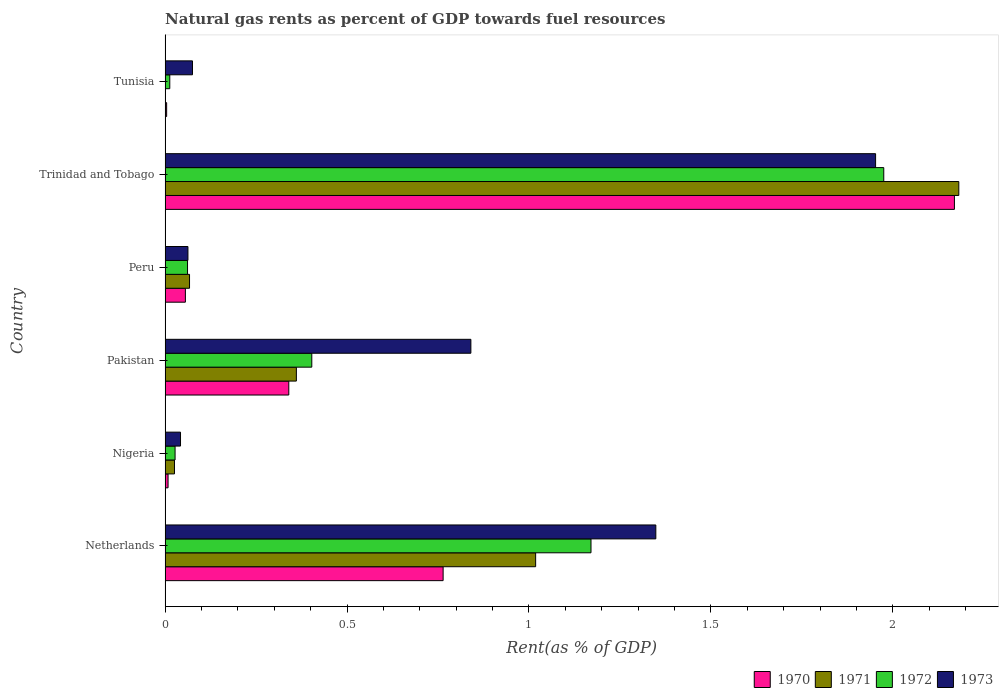Are the number of bars on each tick of the Y-axis equal?
Ensure brevity in your answer.  Yes. What is the label of the 2nd group of bars from the top?
Ensure brevity in your answer.  Trinidad and Tobago. What is the matural gas rent in 1972 in Trinidad and Tobago?
Provide a short and direct response. 1.98. Across all countries, what is the maximum matural gas rent in 1970?
Provide a short and direct response. 2.17. Across all countries, what is the minimum matural gas rent in 1973?
Offer a very short reply. 0.04. In which country was the matural gas rent in 1970 maximum?
Your answer should be very brief. Trinidad and Tobago. In which country was the matural gas rent in 1972 minimum?
Keep it short and to the point. Tunisia. What is the total matural gas rent in 1971 in the graph?
Ensure brevity in your answer.  3.65. What is the difference between the matural gas rent in 1971 in Netherlands and that in Trinidad and Tobago?
Your answer should be compact. -1.16. What is the difference between the matural gas rent in 1971 in Tunisia and the matural gas rent in 1972 in Netherlands?
Offer a very short reply. -1.17. What is the average matural gas rent in 1970 per country?
Make the answer very short. 0.56. What is the difference between the matural gas rent in 1973 and matural gas rent in 1971 in Netherlands?
Offer a very short reply. 0.33. What is the ratio of the matural gas rent in 1973 in Nigeria to that in Pakistan?
Offer a terse response. 0.05. Is the difference between the matural gas rent in 1973 in Nigeria and Trinidad and Tobago greater than the difference between the matural gas rent in 1971 in Nigeria and Trinidad and Tobago?
Offer a very short reply. Yes. What is the difference between the highest and the second highest matural gas rent in 1972?
Your response must be concise. 0.8. What is the difference between the highest and the lowest matural gas rent in 1972?
Give a very brief answer. 1.96. In how many countries, is the matural gas rent in 1973 greater than the average matural gas rent in 1973 taken over all countries?
Offer a terse response. 3. Is the sum of the matural gas rent in 1972 in Pakistan and Trinidad and Tobago greater than the maximum matural gas rent in 1971 across all countries?
Your answer should be compact. Yes. Is it the case that in every country, the sum of the matural gas rent in 1971 and matural gas rent in 1970 is greater than the sum of matural gas rent in 1972 and matural gas rent in 1973?
Offer a terse response. No. Are all the bars in the graph horizontal?
Keep it short and to the point. Yes. Are the values on the major ticks of X-axis written in scientific E-notation?
Your response must be concise. No. Does the graph contain any zero values?
Keep it short and to the point. No. Does the graph contain grids?
Your response must be concise. No. How many legend labels are there?
Provide a succinct answer. 4. What is the title of the graph?
Your answer should be very brief. Natural gas rents as percent of GDP towards fuel resources. Does "2004" appear as one of the legend labels in the graph?
Your answer should be compact. No. What is the label or title of the X-axis?
Your response must be concise. Rent(as % of GDP). What is the Rent(as % of GDP) in 1970 in Netherlands?
Keep it short and to the point. 0.76. What is the Rent(as % of GDP) in 1971 in Netherlands?
Keep it short and to the point. 1.02. What is the Rent(as % of GDP) of 1972 in Netherlands?
Provide a succinct answer. 1.17. What is the Rent(as % of GDP) of 1973 in Netherlands?
Give a very brief answer. 1.35. What is the Rent(as % of GDP) of 1970 in Nigeria?
Your answer should be compact. 0.01. What is the Rent(as % of GDP) of 1971 in Nigeria?
Provide a short and direct response. 0.03. What is the Rent(as % of GDP) in 1972 in Nigeria?
Make the answer very short. 0.03. What is the Rent(as % of GDP) of 1973 in Nigeria?
Provide a succinct answer. 0.04. What is the Rent(as % of GDP) of 1970 in Pakistan?
Provide a succinct answer. 0.34. What is the Rent(as % of GDP) in 1971 in Pakistan?
Provide a short and direct response. 0.36. What is the Rent(as % of GDP) of 1972 in Pakistan?
Your answer should be compact. 0.4. What is the Rent(as % of GDP) in 1973 in Pakistan?
Ensure brevity in your answer.  0.84. What is the Rent(as % of GDP) in 1970 in Peru?
Offer a terse response. 0.06. What is the Rent(as % of GDP) in 1971 in Peru?
Keep it short and to the point. 0.07. What is the Rent(as % of GDP) in 1972 in Peru?
Provide a succinct answer. 0.06. What is the Rent(as % of GDP) of 1973 in Peru?
Your response must be concise. 0.06. What is the Rent(as % of GDP) in 1970 in Trinidad and Tobago?
Your answer should be very brief. 2.17. What is the Rent(as % of GDP) in 1971 in Trinidad and Tobago?
Provide a short and direct response. 2.18. What is the Rent(as % of GDP) of 1972 in Trinidad and Tobago?
Offer a terse response. 1.98. What is the Rent(as % of GDP) of 1973 in Trinidad and Tobago?
Your answer should be very brief. 1.95. What is the Rent(as % of GDP) in 1970 in Tunisia?
Keep it short and to the point. 0. What is the Rent(as % of GDP) in 1971 in Tunisia?
Your response must be concise. 0. What is the Rent(as % of GDP) of 1972 in Tunisia?
Your answer should be very brief. 0.01. What is the Rent(as % of GDP) in 1973 in Tunisia?
Keep it short and to the point. 0.08. Across all countries, what is the maximum Rent(as % of GDP) in 1970?
Keep it short and to the point. 2.17. Across all countries, what is the maximum Rent(as % of GDP) of 1971?
Keep it short and to the point. 2.18. Across all countries, what is the maximum Rent(as % of GDP) of 1972?
Provide a short and direct response. 1.98. Across all countries, what is the maximum Rent(as % of GDP) of 1973?
Keep it short and to the point. 1.95. Across all countries, what is the minimum Rent(as % of GDP) of 1970?
Offer a very short reply. 0. Across all countries, what is the minimum Rent(as % of GDP) of 1971?
Your response must be concise. 0. Across all countries, what is the minimum Rent(as % of GDP) in 1972?
Provide a succinct answer. 0.01. Across all countries, what is the minimum Rent(as % of GDP) of 1973?
Keep it short and to the point. 0.04. What is the total Rent(as % of GDP) of 1970 in the graph?
Offer a terse response. 3.34. What is the total Rent(as % of GDP) in 1971 in the graph?
Keep it short and to the point. 3.65. What is the total Rent(as % of GDP) in 1972 in the graph?
Provide a succinct answer. 3.65. What is the total Rent(as % of GDP) of 1973 in the graph?
Make the answer very short. 4.32. What is the difference between the Rent(as % of GDP) of 1970 in Netherlands and that in Nigeria?
Offer a terse response. 0.76. What is the difference between the Rent(as % of GDP) of 1971 in Netherlands and that in Nigeria?
Provide a short and direct response. 0.99. What is the difference between the Rent(as % of GDP) in 1972 in Netherlands and that in Nigeria?
Make the answer very short. 1.14. What is the difference between the Rent(as % of GDP) of 1973 in Netherlands and that in Nigeria?
Offer a very short reply. 1.31. What is the difference between the Rent(as % of GDP) of 1970 in Netherlands and that in Pakistan?
Offer a terse response. 0.42. What is the difference between the Rent(as % of GDP) in 1971 in Netherlands and that in Pakistan?
Provide a short and direct response. 0.66. What is the difference between the Rent(as % of GDP) of 1972 in Netherlands and that in Pakistan?
Provide a succinct answer. 0.77. What is the difference between the Rent(as % of GDP) of 1973 in Netherlands and that in Pakistan?
Your answer should be compact. 0.51. What is the difference between the Rent(as % of GDP) in 1970 in Netherlands and that in Peru?
Ensure brevity in your answer.  0.71. What is the difference between the Rent(as % of GDP) of 1971 in Netherlands and that in Peru?
Your response must be concise. 0.95. What is the difference between the Rent(as % of GDP) in 1972 in Netherlands and that in Peru?
Offer a terse response. 1.11. What is the difference between the Rent(as % of GDP) of 1973 in Netherlands and that in Peru?
Provide a short and direct response. 1.29. What is the difference between the Rent(as % of GDP) of 1970 in Netherlands and that in Trinidad and Tobago?
Make the answer very short. -1.41. What is the difference between the Rent(as % of GDP) of 1971 in Netherlands and that in Trinidad and Tobago?
Your answer should be compact. -1.16. What is the difference between the Rent(as % of GDP) of 1972 in Netherlands and that in Trinidad and Tobago?
Offer a terse response. -0.8. What is the difference between the Rent(as % of GDP) in 1973 in Netherlands and that in Trinidad and Tobago?
Ensure brevity in your answer.  -0.6. What is the difference between the Rent(as % of GDP) of 1970 in Netherlands and that in Tunisia?
Your answer should be compact. 0.76. What is the difference between the Rent(as % of GDP) of 1971 in Netherlands and that in Tunisia?
Make the answer very short. 1.02. What is the difference between the Rent(as % of GDP) in 1972 in Netherlands and that in Tunisia?
Make the answer very short. 1.16. What is the difference between the Rent(as % of GDP) in 1973 in Netherlands and that in Tunisia?
Give a very brief answer. 1.27. What is the difference between the Rent(as % of GDP) of 1970 in Nigeria and that in Pakistan?
Your answer should be compact. -0.33. What is the difference between the Rent(as % of GDP) of 1971 in Nigeria and that in Pakistan?
Provide a short and direct response. -0.34. What is the difference between the Rent(as % of GDP) in 1972 in Nigeria and that in Pakistan?
Your answer should be very brief. -0.38. What is the difference between the Rent(as % of GDP) of 1973 in Nigeria and that in Pakistan?
Offer a terse response. -0.8. What is the difference between the Rent(as % of GDP) in 1970 in Nigeria and that in Peru?
Your answer should be very brief. -0.05. What is the difference between the Rent(as % of GDP) in 1971 in Nigeria and that in Peru?
Provide a succinct answer. -0.04. What is the difference between the Rent(as % of GDP) in 1972 in Nigeria and that in Peru?
Offer a very short reply. -0.03. What is the difference between the Rent(as % of GDP) in 1973 in Nigeria and that in Peru?
Provide a succinct answer. -0.02. What is the difference between the Rent(as % of GDP) in 1970 in Nigeria and that in Trinidad and Tobago?
Provide a succinct answer. -2.16. What is the difference between the Rent(as % of GDP) in 1971 in Nigeria and that in Trinidad and Tobago?
Your answer should be very brief. -2.16. What is the difference between the Rent(as % of GDP) in 1972 in Nigeria and that in Trinidad and Tobago?
Keep it short and to the point. -1.95. What is the difference between the Rent(as % of GDP) in 1973 in Nigeria and that in Trinidad and Tobago?
Keep it short and to the point. -1.91. What is the difference between the Rent(as % of GDP) of 1970 in Nigeria and that in Tunisia?
Keep it short and to the point. 0. What is the difference between the Rent(as % of GDP) in 1971 in Nigeria and that in Tunisia?
Ensure brevity in your answer.  0.03. What is the difference between the Rent(as % of GDP) of 1972 in Nigeria and that in Tunisia?
Offer a terse response. 0.01. What is the difference between the Rent(as % of GDP) in 1973 in Nigeria and that in Tunisia?
Provide a succinct answer. -0.03. What is the difference between the Rent(as % of GDP) of 1970 in Pakistan and that in Peru?
Provide a short and direct response. 0.28. What is the difference between the Rent(as % of GDP) in 1971 in Pakistan and that in Peru?
Your response must be concise. 0.29. What is the difference between the Rent(as % of GDP) in 1972 in Pakistan and that in Peru?
Ensure brevity in your answer.  0.34. What is the difference between the Rent(as % of GDP) of 1973 in Pakistan and that in Peru?
Your answer should be compact. 0.78. What is the difference between the Rent(as % of GDP) of 1970 in Pakistan and that in Trinidad and Tobago?
Offer a very short reply. -1.83. What is the difference between the Rent(as % of GDP) in 1971 in Pakistan and that in Trinidad and Tobago?
Ensure brevity in your answer.  -1.82. What is the difference between the Rent(as % of GDP) of 1972 in Pakistan and that in Trinidad and Tobago?
Give a very brief answer. -1.57. What is the difference between the Rent(as % of GDP) in 1973 in Pakistan and that in Trinidad and Tobago?
Make the answer very short. -1.11. What is the difference between the Rent(as % of GDP) of 1970 in Pakistan and that in Tunisia?
Ensure brevity in your answer.  0.34. What is the difference between the Rent(as % of GDP) in 1971 in Pakistan and that in Tunisia?
Make the answer very short. 0.36. What is the difference between the Rent(as % of GDP) of 1972 in Pakistan and that in Tunisia?
Make the answer very short. 0.39. What is the difference between the Rent(as % of GDP) of 1973 in Pakistan and that in Tunisia?
Ensure brevity in your answer.  0.77. What is the difference between the Rent(as % of GDP) in 1970 in Peru and that in Trinidad and Tobago?
Make the answer very short. -2.11. What is the difference between the Rent(as % of GDP) of 1971 in Peru and that in Trinidad and Tobago?
Provide a short and direct response. -2.11. What is the difference between the Rent(as % of GDP) in 1972 in Peru and that in Trinidad and Tobago?
Keep it short and to the point. -1.91. What is the difference between the Rent(as % of GDP) of 1973 in Peru and that in Trinidad and Tobago?
Provide a short and direct response. -1.89. What is the difference between the Rent(as % of GDP) in 1970 in Peru and that in Tunisia?
Offer a terse response. 0.05. What is the difference between the Rent(as % of GDP) of 1971 in Peru and that in Tunisia?
Give a very brief answer. 0.07. What is the difference between the Rent(as % of GDP) in 1972 in Peru and that in Tunisia?
Give a very brief answer. 0.05. What is the difference between the Rent(as % of GDP) in 1973 in Peru and that in Tunisia?
Provide a short and direct response. -0.01. What is the difference between the Rent(as % of GDP) in 1970 in Trinidad and Tobago and that in Tunisia?
Make the answer very short. 2.17. What is the difference between the Rent(as % of GDP) in 1971 in Trinidad and Tobago and that in Tunisia?
Provide a succinct answer. 2.18. What is the difference between the Rent(as % of GDP) of 1972 in Trinidad and Tobago and that in Tunisia?
Offer a very short reply. 1.96. What is the difference between the Rent(as % of GDP) in 1973 in Trinidad and Tobago and that in Tunisia?
Make the answer very short. 1.88. What is the difference between the Rent(as % of GDP) of 1970 in Netherlands and the Rent(as % of GDP) of 1971 in Nigeria?
Offer a terse response. 0.74. What is the difference between the Rent(as % of GDP) in 1970 in Netherlands and the Rent(as % of GDP) in 1972 in Nigeria?
Offer a very short reply. 0.74. What is the difference between the Rent(as % of GDP) of 1970 in Netherlands and the Rent(as % of GDP) of 1973 in Nigeria?
Your answer should be compact. 0.72. What is the difference between the Rent(as % of GDP) in 1971 in Netherlands and the Rent(as % of GDP) in 1972 in Nigeria?
Provide a short and direct response. 0.99. What is the difference between the Rent(as % of GDP) in 1972 in Netherlands and the Rent(as % of GDP) in 1973 in Nigeria?
Make the answer very short. 1.13. What is the difference between the Rent(as % of GDP) of 1970 in Netherlands and the Rent(as % of GDP) of 1971 in Pakistan?
Ensure brevity in your answer.  0.4. What is the difference between the Rent(as % of GDP) in 1970 in Netherlands and the Rent(as % of GDP) in 1972 in Pakistan?
Your response must be concise. 0.36. What is the difference between the Rent(as % of GDP) in 1970 in Netherlands and the Rent(as % of GDP) in 1973 in Pakistan?
Your response must be concise. -0.08. What is the difference between the Rent(as % of GDP) of 1971 in Netherlands and the Rent(as % of GDP) of 1972 in Pakistan?
Your response must be concise. 0.62. What is the difference between the Rent(as % of GDP) of 1971 in Netherlands and the Rent(as % of GDP) of 1973 in Pakistan?
Give a very brief answer. 0.18. What is the difference between the Rent(as % of GDP) of 1972 in Netherlands and the Rent(as % of GDP) of 1973 in Pakistan?
Give a very brief answer. 0.33. What is the difference between the Rent(as % of GDP) of 1970 in Netherlands and the Rent(as % of GDP) of 1971 in Peru?
Make the answer very short. 0.7. What is the difference between the Rent(as % of GDP) in 1970 in Netherlands and the Rent(as % of GDP) in 1972 in Peru?
Provide a succinct answer. 0.7. What is the difference between the Rent(as % of GDP) of 1970 in Netherlands and the Rent(as % of GDP) of 1973 in Peru?
Your answer should be compact. 0.7. What is the difference between the Rent(as % of GDP) in 1971 in Netherlands and the Rent(as % of GDP) in 1972 in Peru?
Offer a terse response. 0.96. What is the difference between the Rent(as % of GDP) of 1971 in Netherlands and the Rent(as % of GDP) of 1973 in Peru?
Offer a very short reply. 0.96. What is the difference between the Rent(as % of GDP) in 1972 in Netherlands and the Rent(as % of GDP) in 1973 in Peru?
Your response must be concise. 1.11. What is the difference between the Rent(as % of GDP) of 1970 in Netherlands and the Rent(as % of GDP) of 1971 in Trinidad and Tobago?
Provide a succinct answer. -1.42. What is the difference between the Rent(as % of GDP) of 1970 in Netherlands and the Rent(as % of GDP) of 1972 in Trinidad and Tobago?
Your answer should be very brief. -1.21. What is the difference between the Rent(as % of GDP) of 1970 in Netherlands and the Rent(as % of GDP) of 1973 in Trinidad and Tobago?
Give a very brief answer. -1.19. What is the difference between the Rent(as % of GDP) of 1971 in Netherlands and the Rent(as % of GDP) of 1972 in Trinidad and Tobago?
Provide a succinct answer. -0.96. What is the difference between the Rent(as % of GDP) in 1971 in Netherlands and the Rent(as % of GDP) in 1973 in Trinidad and Tobago?
Offer a very short reply. -0.93. What is the difference between the Rent(as % of GDP) of 1972 in Netherlands and the Rent(as % of GDP) of 1973 in Trinidad and Tobago?
Make the answer very short. -0.78. What is the difference between the Rent(as % of GDP) of 1970 in Netherlands and the Rent(as % of GDP) of 1971 in Tunisia?
Provide a succinct answer. 0.76. What is the difference between the Rent(as % of GDP) of 1970 in Netherlands and the Rent(as % of GDP) of 1972 in Tunisia?
Ensure brevity in your answer.  0.75. What is the difference between the Rent(as % of GDP) in 1970 in Netherlands and the Rent(as % of GDP) in 1973 in Tunisia?
Make the answer very short. 0.69. What is the difference between the Rent(as % of GDP) of 1971 in Netherlands and the Rent(as % of GDP) of 1972 in Tunisia?
Offer a terse response. 1.01. What is the difference between the Rent(as % of GDP) in 1971 in Netherlands and the Rent(as % of GDP) in 1973 in Tunisia?
Give a very brief answer. 0.94. What is the difference between the Rent(as % of GDP) in 1972 in Netherlands and the Rent(as % of GDP) in 1973 in Tunisia?
Keep it short and to the point. 1.1. What is the difference between the Rent(as % of GDP) of 1970 in Nigeria and the Rent(as % of GDP) of 1971 in Pakistan?
Provide a short and direct response. -0.35. What is the difference between the Rent(as % of GDP) of 1970 in Nigeria and the Rent(as % of GDP) of 1972 in Pakistan?
Provide a succinct answer. -0.4. What is the difference between the Rent(as % of GDP) in 1970 in Nigeria and the Rent(as % of GDP) in 1973 in Pakistan?
Make the answer very short. -0.83. What is the difference between the Rent(as % of GDP) in 1971 in Nigeria and the Rent(as % of GDP) in 1972 in Pakistan?
Your answer should be very brief. -0.38. What is the difference between the Rent(as % of GDP) in 1971 in Nigeria and the Rent(as % of GDP) in 1973 in Pakistan?
Give a very brief answer. -0.81. What is the difference between the Rent(as % of GDP) in 1972 in Nigeria and the Rent(as % of GDP) in 1973 in Pakistan?
Your answer should be compact. -0.81. What is the difference between the Rent(as % of GDP) in 1970 in Nigeria and the Rent(as % of GDP) in 1971 in Peru?
Offer a very short reply. -0.06. What is the difference between the Rent(as % of GDP) of 1970 in Nigeria and the Rent(as % of GDP) of 1972 in Peru?
Offer a terse response. -0.05. What is the difference between the Rent(as % of GDP) in 1970 in Nigeria and the Rent(as % of GDP) in 1973 in Peru?
Provide a succinct answer. -0.05. What is the difference between the Rent(as % of GDP) in 1971 in Nigeria and the Rent(as % of GDP) in 1972 in Peru?
Provide a succinct answer. -0.04. What is the difference between the Rent(as % of GDP) in 1971 in Nigeria and the Rent(as % of GDP) in 1973 in Peru?
Provide a short and direct response. -0.04. What is the difference between the Rent(as % of GDP) in 1972 in Nigeria and the Rent(as % of GDP) in 1973 in Peru?
Your answer should be compact. -0.04. What is the difference between the Rent(as % of GDP) in 1970 in Nigeria and the Rent(as % of GDP) in 1971 in Trinidad and Tobago?
Your answer should be very brief. -2.17. What is the difference between the Rent(as % of GDP) of 1970 in Nigeria and the Rent(as % of GDP) of 1972 in Trinidad and Tobago?
Provide a short and direct response. -1.97. What is the difference between the Rent(as % of GDP) of 1970 in Nigeria and the Rent(as % of GDP) of 1973 in Trinidad and Tobago?
Make the answer very short. -1.94. What is the difference between the Rent(as % of GDP) of 1971 in Nigeria and the Rent(as % of GDP) of 1972 in Trinidad and Tobago?
Your answer should be very brief. -1.95. What is the difference between the Rent(as % of GDP) in 1971 in Nigeria and the Rent(as % of GDP) in 1973 in Trinidad and Tobago?
Provide a succinct answer. -1.93. What is the difference between the Rent(as % of GDP) in 1972 in Nigeria and the Rent(as % of GDP) in 1973 in Trinidad and Tobago?
Ensure brevity in your answer.  -1.93. What is the difference between the Rent(as % of GDP) of 1970 in Nigeria and the Rent(as % of GDP) of 1971 in Tunisia?
Ensure brevity in your answer.  0.01. What is the difference between the Rent(as % of GDP) in 1970 in Nigeria and the Rent(as % of GDP) in 1972 in Tunisia?
Your response must be concise. -0. What is the difference between the Rent(as % of GDP) in 1970 in Nigeria and the Rent(as % of GDP) in 1973 in Tunisia?
Keep it short and to the point. -0.07. What is the difference between the Rent(as % of GDP) of 1971 in Nigeria and the Rent(as % of GDP) of 1972 in Tunisia?
Provide a succinct answer. 0.01. What is the difference between the Rent(as % of GDP) in 1971 in Nigeria and the Rent(as % of GDP) in 1973 in Tunisia?
Provide a succinct answer. -0.05. What is the difference between the Rent(as % of GDP) in 1972 in Nigeria and the Rent(as % of GDP) in 1973 in Tunisia?
Provide a succinct answer. -0.05. What is the difference between the Rent(as % of GDP) of 1970 in Pakistan and the Rent(as % of GDP) of 1971 in Peru?
Offer a terse response. 0.27. What is the difference between the Rent(as % of GDP) of 1970 in Pakistan and the Rent(as % of GDP) of 1972 in Peru?
Offer a terse response. 0.28. What is the difference between the Rent(as % of GDP) in 1970 in Pakistan and the Rent(as % of GDP) in 1973 in Peru?
Keep it short and to the point. 0.28. What is the difference between the Rent(as % of GDP) in 1971 in Pakistan and the Rent(as % of GDP) in 1972 in Peru?
Give a very brief answer. 0.3. What is the difference between the Rent(as % of GDP) of 1971 in Pakistan and the Rent(as % of GDP) of 1973 in Peru?
Provide a succinct answer. 0.3. What is the difference between the Rent(as % of GDP) of 1972 in Pakistan and the Rent(as % of GDP) of 1973 in Peru?
Give a very brief answer. 0.34. What is the difference between the Rent(as % of GDP) of 1970 in Pakistan and the Rent(as % of GDP) of 1971 in Trinidad and Tobago?
Make the answer very short. -1.84. What is the difference between the Rent(as % of GDP) of 1970 in Pakistan and the Rent(as % of GDP) of 1972 in Trinidad and Tobago?
Ensure brevity in your answer.  -1.64. What is the difference between the Rent(as % of GDP) in 1970 in Pakistan and the Rent(as % of GDP) in 1973 in Trinidad and Tobago?
Your answer should be very brief. -1.61. What is the difference between the Rent(as % of GDP) of 1971 in Pakistan and the Rent(as % of GDP) of 1972 in Trinidad and Tobago?
Your answer should be compact. -1.61. What is the difference between the Rent(as % of GDP) of 1971 in Pakistan and the Rent(as % of GDP) of 1973 in Trinidad and Tobago?
Provide a short and direct response. -1.59. What is the difference between the Rent(as % of GDP) in 1972 in Pakistan and the Rent(as % of GDP) in 1973 in Trinidad and Tobago?
Provide a short and direct response. -1.55. What is the difference between the Rent(as % of GDP) of 1970 in Pakistan and the Rent(as % of GDP) of 1971 in Tunisia?
Provide a short and direct response. 0.34. What is the difference between the Rent(as % of GDP) of 1970 in Pakistan and the Rent(as % of GDP) of 1972 in Tunisia?
Offer a terse response. 0.33. What is the difference between the Rent(as % of GDP) of 1970 in Pakistan and the Rent(as % of GDP) of 1973 in Tunisia?
Provide a succinct answer. 0.26. What is the difference between the Rent(as % of GDP) of 1971 in Pakistan and the Rent(as % of GDP) of 1972 in Tunisia?
Keep it short and to the point. 0.35. What is the difference between the Rent(as % of GDP) of 1971 in Pakistan and the Rent(as % of GDP) of 1973 in Tunisia?
Your response must be concise. 0.29. What is the difference between the Rent(as % of GDP) of 1972 in Pakistan and the Rent(as % of GDP) of 1973 in Tunisia?
Ensure brevity in your answer.  0.33. What is the difference between the Rent(as % of GDP) of 1970 in Peru and the Rent(as % of GDP) of 1971 in Trinidad and Tobago?
Keep it short and to the point. -2.13. What is the difference between the Rent(as % of GDP) of 1970 in Peru and the Rent(as % of GDP) of 1972 in Trinidad and Tobago?
Make the answer very short. -1.92. What is the difference between the Rent(as % of GDP) of 1970 in Peru and the Rent(as % of GDP) of 1973 in Trinidad and Tobago?
Keep it short and to the point. -1.9. What is the difference between the Rent(as % of GDP) in 1971 in Peru and the Rent(as % of GDP) in 1972 in Trinidad and Tobago?
Your answer should be very brief. -1.91. What is the difference between the Rent(as % of GDP) of 1971 in Peru and the Rent(as % of GDP) of 1973 in Trinidad and Tobago?
Provide a succinct answer. -1.89. What is the difference between the Rent(as % of GDP) in 1972 in Peru and the Rent(as % of GDP) in 1973 in Trinidad and Tobago?
Your response must be concise. -1.89. What is the difference between the Rent(as % of GDP) in 1970 in Peru and the Rent(as % of GDP) in 1971 in Tunisia?
Ensure brevity in your answer.  0.06. What is the difference between the Rent(as % of GDP) of 1970 in Peru and the Rent(as % of GDP) of 1972 in Tunisia?
Provide a succinct answer. 0.04. What is the difference between the Rent(as % of GDP) in 1970 in Peru and the Rent(as % of GDP) in 1973 in Tunisia?
Give a very brief answer. -0.02. What is the difference between the Rent(as % of GDP) of 1971 in Peru and the Rent(as % of GDP) of 1972 in Tunisia?
Your answer should be very brief. 0.05. What is the difference between the Rent(as % of GDP) in 1971 in Peru and the Rent(as % of GDP) in 1973 in Tunisia?
Provide a short and direct response. -0.01. What is the difference between the Rent(as % of GDP) in 1972 in Peru and the Rent(as % of GDP) in 1973 in Tunisia?
Your answer should be very brief. -0.01. What is the difference between the Rent(as % of GDP) of 1970 in Trinidad and Tobago and the Rent(as % of GDP) of 1971 in Tunisia?
Make the answer very short. 2.17. What is the difference between the Rent(as % of GDP) of 1970 in Trinidad and Tobago and the Rent(as % of GDP) of 1972 in Tunisia?
Your response must be concise. 2.16. What is the difference between the Rent(as % of GDP) in 1970 in Trinidad and Tobago and the Rent(as % of GDP) in 1973 in Tunisia?
Keep it short and to the point. 2.09. What is the difference between the Rent(as % of GDP) of 1971 in Trinidad and Tobago and the Rent(as % of GDP) of 1972 in Tunisia?
Keep it short and to the point. 2.17. What is the difference between the Rent(as % of GDP) in 1971 in Trinidad and Tobago and the Rent(as % of GDP) in 1973 in Tunisia?
Your answer should be compact. 2.11. What is the difference between the Rent(as % of GDP) of 1972 in Trinidad and Tobago and the Rent(as % of GDP) of 1973 in Tunisia?
Your answer should be very brief. 1.9. What is the average Rent(as % of GDP) of 1970 per country?
Provide a short and direct response. 0.56. What is the average Rent(as % of GDP) in 1971 per country?
Your answer should be very brief. 0.61. What is the average Rent(as % of GDP) in 1972 per country?
Give a very brief answer. 0.61. What is the average Rent(as % of GDP) in 1973 per country?
Provide a succinct answer. 0.72. What is the difference between the Rent(as % of GDP) of 1970 and Rent(as % of GDP) of 1971 in Netherlands?
Make the answer very short. -0.25. What is the difference between the Rent(as % of GDP) of 1970 and Rent(as % of GDP) of 1972 in Netherlands?
Your response must be concise. -0.41. What is the difference between the Rent(as % of GDP) of 1970 and Rent(as % of GDP) of 1973 in Netherlands?
Offer a very short reply. -0.58. What is the difference between the Rent(as % of GDP) in 1971 and Rent(as % of GDP) in 1972 in Netherlands?
Ensure brevity in your answer.  -0.15. What is the difference between the Rent(as % of GDP) of 1971 and Rent(as % of GDP) of 1973 in Netherlands?
Provide a short and direct response. -0.33. What is the difference between the Rent(as % of GDP) in 1972 and Rent(as % of GDP) in 1973 in Netherlands?
Your answer should be very brief. -0.18. What is the difference between the Rent(as % of GDP) in 1970 and Rent(as % of GDP) in 1971 in Nigeria?
Provide a succinct answer. -0.02. What is the difference between the Rent(as % of GDP) in 1970 and Rent(as % of GDP) in 1972 in Nigeria?
Provide a short and direct response. -0.02. What is the difference between the Rent(as % of GDP) in 1970 and Rent(as % of GDP) in 1973 in Nigeria?
Your answer should be compact. -0.03. What is the difference between the Rent(as % of GDP) in 1971 and Rent(as % of GDP) in 1972 in Nigeria?
Keep it short and to the point. -0. What is the difference between the Rent(as % of GDP) in 1971 and Rent(as % of GDP) in 1973 in Nigeria?
Provide a succinct answer. -0.02. What is the difference between the Rent(as % of GDP) in 1972 and Rent(as % of GDP) in 1973 in Nigeria?
Keep it short and to the point. -0.01. What is the difference between the Rent(as % of GDP) in 1970 and Rent(as % of GDP) in 1971 in Pakistan?
Ensure brevity in your answer.  -0.02. What is the difference between the Rent(as % of GDP) in 1970 and Rent(as % of GDP) in 1972 in Pakistan?
Keep it short and to the point. -0.06. What is the difference between the Rent(as % of GDP) in 1970 and Rent(as % of GDP) in 1973 in Pakistan?
Your answer should be very brief. -0.5. What is the difference between the Rent(as % of GDP) in 1971 and Rent(as % of GDP) in 1972 in Pakistan?
Offer a very short reply. -0.04. What is the difference between the Rent(as % of GDP) in 1971 and Rent(as % of GDP) in 1973 in Pakistan?
Offer a terse response. -0.48. What is the difference between the Rent(as % of GDP) in 1972 and Rent(as % of GDP) in 1973 in Pakistan?
Offer a terse response. -0.44. What is the difference between the Rent(as % of GDP) in 1970 and Rent(as % of GDP) in 1971 in Peru?
Provide a succinct answer. -0.01. What is the difference between the Rent(as % of GDP) of 1970 and Rent(as % of GDP) of 1972 in Peru?
Offer a terse response. -0.01. What is the difference between the Rent(as % of GDP) in 1970 and Rent(as % of GDP) in 1973 in Peru?
Make the answer very short. -0.01. What is the difference between the Rent(as % of GDP) of 1971 and Rent(as % of GDP) of 1972 in Peru?
Your answer should be very brief. 0.01. What is the difference between the Rent(as % of GDP) in 1971 and Rent(as % of GDP) in 1973 in Peru?
Your answer should be compact. 0. What is the difference between the Rent(as % of GDP) in 1972 and Rent(as % of GDP) in 1973 in Peru?
Your response must be concise. -0. What is the difference between the Rent(as % of GDP) of 1970 and Rent(as % of GDP) of 1971 in Trinidad and Tobago?
Provide a succinct answer. -0.01. What is the difference between the Rent(as % of GDP) in 1970 and Rent(as % of GDP) in 1972 in Trinidad and Tobago?
Offer a terse response. 0.19. What is the difference between the Rent(as % of GDP) in 1970 and Rent(as % of GDP) in 1973 in Trinidad and Tobago?
Give a very brief answer. 0.22. What is the difference between the Rent(as % of GDP) in 1971 and Rent(as % of GDP) in 1972 in Trinidad and Tobago?
Your answer should be compact. 0.21. What is the difference between the Rent(as % of GDP) in 1971 and Rent(as % of GDP) in 1973 in Trinidad and Tobago?
Provide a succinct answer. 0.23. What is the difference between the Rent(as % of GDP) in 1972 and Rent(as % of GDP) in 1973 in Trinidad and Tobago?
Keep it short and to the point. 0.02. What is the difference between the Rent(as % of GDP) of 1970 and Rent(as % of GDP) of 1971 in Tunisia?
Offer a very short reply. 0. What is the difference between the Rent(as % of GDP) in 1970 and Rent(as % of GDP) in 1972 in Tunisia?
Keep it short and to the point. -0.01. What is the difference between the Rent(as % of GDP) in 1970 and Rent(as % of GDP) in 1973 in Tunisia?
Give a very brief answer. -0.07. What is the difference between the Rent(as % of GDP) of 1971 and Rent(as % of GDP) of 1972 in Tunisia?
Offer a terse response. -0.01. What is the difference between the Rent(as % of GDP) of 1971 and Rent(as % of GDP) of 1973 in Tunisia?
Your answer should be compact. -0.07. What is the difference between the Rent(as % of GDP) in 1972 and Rent(as % of GDP) in 1973 in Tunisia?
Your answer should be compact. -0.06. What is the ratio of the Rent(as % of GDP) in 1970 in Netherlands to that in Nigeria?
Make the answer very short. 93.94. What is the ratio of the Rent(as % of GDP) in 1971 in Netherlands to that in Nigeria?
Keep it short and to the point. 39.48. What is the ratio of the Rent(as % of GDP) of 1972 in Netherlands to that in Nigeria?
Give a very brief answer. 42.7. What is the ratio of the Rent(as % of GDP) of 1973 in Netherlands to that in Nigeria?
Your answer should be compact. 31.84. What is the ratio of the Rent(as % of GDP) of 1970 in Netherlands to that in Pakistan?
Ensure brevity in your answer.  2.25. What is the ratio of the Rent(as % of GDP) of 1971 in Netherlands to that in Pakistan?
Ensure brevity in your answer.  2.82. What is the ratio of the Rent(as % of GDP) in 1972 in Netherlands to that in Pakistan?
Your answer should be compact. 2.9. What is the ratio of the Rent(as % of GDP) of 1973 in Netherlands to that in Pakistan?
Provide a short and direct response. 1.6. What is the ratio of the Rent(as % of GDP) in 1970 in Netherlands to that in Peru?
Ensure brevity in your answer.  13.7. What is the ratio of the Rent(as % of GDP) of 1971 in Netherlands to that in Peru?
Make the answer very short. 15.16. What is the ratio of the Rent(as % of GDP) in 1972 in Netherlands to that in Peru?
Your answer should be compact. 18.98. What is the ratio of the Rent(as % of GDP) in 1973 in Netherlands to that in Peru?
Give a very brief answer. 21.49. What is the ratio of the Rent(as % of GDP) in 1970 in Netherlands to that in Trinidad and Tobago?
Ensure brevity in your answer.  0.35. What is the ratio of the Rent(as % of GDP) of 1971 in Netherlands to that in Trinidad and Tobago?
Provide a short and direct response. 0.47. What is the ratio of the Rent(as % of GDP) in 1972 in Netherlands to that in Trinidad and Tobago?
Provide a short and direct response. 0.59. What is the ratio of the Rent(as % of GDP) in 1973 in Netherlands to that in Trinidad and Tobago?
Offer a terse response. 0.69. What is the ratio of the Rent(as % of GDP) in 1970 in Netherlands to that in Tunisia?
Your answer should be very brief. 180.16. What is the ratio of the Rent(as % of GDP) of 1971 in Netherlands to that in Tunisia?
Your answer should be very brief. 1372.84. What is the ratio of the Rent(as % of GDP) of 1972 in Netherlands to that in Tunisia?
Your response must be concise. 90.9. What is the ratio of the Rent(as % of GDP) in 1973 in Netherlands to that in Tunisia?
Offer a very short reply. 17.92. What is the ratio of the Rent(as % of GDP) in 1970 in Nigeria to that in Pakistan?
Your response must be concise. 0.02. What is the ratio of the Rent(as % of GDP) in 1971 in Nigeria to that in Pakistan?
Your answer should be very brief. 0.07. What is the ratio of the Rent(as % of GDP) in 1972 in Nigeria to that in Pakistan?
Your answer should be compact. 0.07. What is the ratio of the Rent(as % of GDP) of 1973 in Nigeria to that in Pakistan?
Provide a short and direct response. 0.05. What is the ratio of the Rent(as % of GDP) of 1970 in Nigeria to that in Peru?
Your answer should be compact. 0.15. What is the ratio of the Rent(as % of GDP) of 1971 in Nigeria to that in Peru?
Keep it short and to the point. 0.38. What is the ratio of the Rent(as % of GDP) in 1972 in Nigeria to that in Peru?
Keep it short and to the point. 0.44. What is the ratio of the Rent(as % of GDP) in 1973 in Nigeria to that in Peru?
Offer a very short reply. 0.67. What is the ratio of the Rent(as % of GDP) in 1970 in Nigeria to that in Trinidad and Tobago?
Offer a very short reply. 0. What is the ratio of the Rent(as % of GDP) of 1971 in Nigeria to that in Trinidad and Tobago?
Provide a succinct answer. 0.01. What is the ratio of the Rent(as % of GDP) in 1972 in Nigeria to that in Trinidad and Tobago?
Ensure brevity in your answer.  0.01. What is the ratio of the Rent(as % of GDP) in 1973 in Nigeria to that in Trinidad and Tobago?
Ensure brevity in your answer.  0.02. What is the ratio of the Rent(as % of GDP) of 1970 in Nigeria to that in Tunisia?
Ensure brevity in your answer.  1.92. What is the ratio of the Rent(as % of GDP) of 1971 in Nigeria to that in Tunisia?
Provide a succinct answer. 34.77. What is the ratio of the Rent(as % of GDP) of 1972 in Nigeria to that in Tunisia?
Your response must be concise. 2.13. What is the ratio of the Rent(as % of GDP) of 1973 in Nigeria to that in Tunisia?
Give a very brief answer. 0.56. What is the ratio of the Rent(as % of GDP) in 1970 in Pakistan to that in Peru?
Offer a very short reply. 6.1. What is the ratio of the Rent(as % of GDP) of 1971 in Pakistan to that in Peru?
Provide a succinct answer. 5.37. What is the ratio of the Rent(as % of GDP) of 1972 in Pakistan to that in Peru?
Your response must be concise. 6.54. What is the ratio of the Rent(as % of GDP) of 1973 in Pakistan to that in Peru?
Provide a succinct answer. 13.39. What is the ratio of the Rent(as % of GDP) in 1970 in Pakistan to that in Trinidad and Tobago?
Your answer should be compact. 0.16. What is the ratio of the Rent(as % of GDP) of 1971 in Pakistan to that in Trinidad and Tobago?
Your answer should be very brief. 0.17. What is the ratio of the Rent(as % of GDP) in 1972 in Pakistan to that in Trinidad and Tobago?
Keep it short and to the point. 0.2. What is the ratio of the Rent(as % of GDP) in 1973 in Pakistan to that in Trinidad and Tobago?
Offer a terse response. 0.43. What is the ratio of the Rent(as % of GDP) of 1970 in Pakistan to that in Tunisia?
Offer a very short reply. 80.16. What is the ratio of the Rent(as % of GDP) in 1971 in Pakistan to that in Tunisia?
Your response must be concise. 486.4. What is the ratio of the Rent(as % of GDP) of 1972 in Pakistan to that in Tunisia?
Your answer should be compact. 31.31. What is the ratio of the Rent(as % of GDP) in 1973 in Pakistan to that in Tunisia?
Your answer should be compact. 11.17. What is the ratio of the Rent(as % of GDP) of 1970 in Peru to that in Trinidad and Tobago?
Ensure brevity in your answer.  0.03. What is the ratio of the Rent(as % of GDP) of 1971 in Peru to that in Trinidad and Tobago?
Give a very brief answer. 0.03. What is the ratio of the Rent(as % of GDP) in 1972 in Peru to that in Trinidad and Tobago?
Your answer should be very brief. 0.03. What is the ratio of the Rent(as % of GDP) of 1973 in Peru to that in Trinidad and Tobago?
Provide a short and direct response. 0.03. What is the ratio of the Rent(as % of GDP) in 1970 in Peru to that in Tunisia?
Provide a short and direct response. 13.15. What is the ratio of the Rent(as % of GDP) of 1971 in Peru to that in Tunisia?
Ensure brevity in your answer.  90.55. What is the ratio of the Rent(as % of GDP) in 1972 in Peru to that in Tunisia?
Provide a short and direct response. 4.79. What is the ratio of the Rent(as % of GDP) of 1973 in Peru to that in Tunisia?
Your answer should be very brief. 0.83. What is the ratio of the Rent(as % of GDP) in 1970 in Trinidad and Tobago to that in Tunisia?
Offer a very short reply. 511.49. What is the ratio of the Rent(as % of GDP) of 1971 in Trinidad and Tobago to that in Tunisia?
Provide a short and direct response. 2940.6. What is the ratio of the Rent(as % of GDP) in 1972 in Trinidad and Tobago to that in Tunisia?
Your response must be concise. 153.39. What is the ratio of the Rent(as % of GDP) of 1973 in Trinidad and Tobago to that in Tunisia?
Provide a short and direct response. 25.94. What is the difference between the highest and the second highest Rent(as % of GDP) of 1970?
Make the answer very short. 1.41. What is the difference between the highest and the second highest Rent(as % of GDP) in 1971?
Provide a succinct answer. 1.16. What is the difference between the highest and the second highest Rent(as % of GDP) in 1972?
Your answer should be very brief. 0.8. What is the difference between the highest and the second highest Rent(as % of GDP) of 1973?
Make the answer very short. 0.6. What is the difference between the highest and the lowest Rent(as % of GDP) of 1970?
Ensure brevity in your answer.  2.17. What is the difference between the highest and the lowest Rent(as % of GDP) in 1971?
Make the answer very short. 2.18. What is the difference between the highest and the lowest Rent(as % of GDP) of 1972?
Provide a short and direct response. 1.96. What is the difference between the highest and the lowest Rent(as % of GDP) of 1973?
Provide a succinct answer. 1.91. 